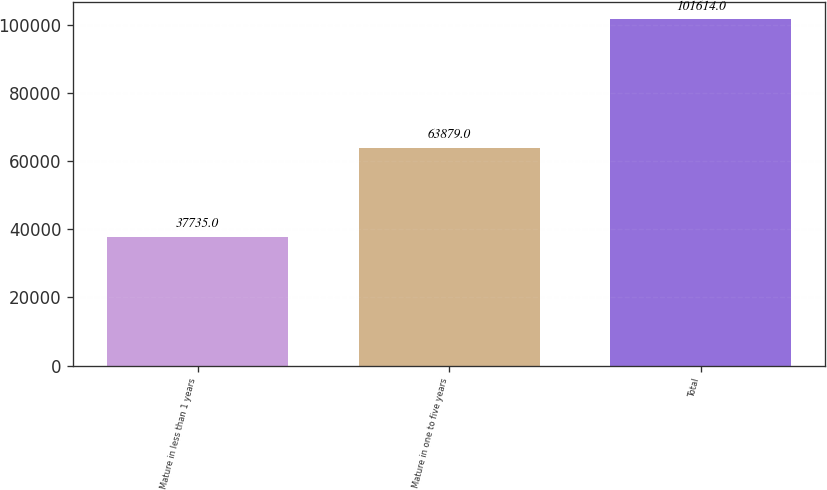Convert chart to OTSL. <chart><loc_0><loc_0><loc_500><loc_500><bar_chart><fcel>Mature in less than 1 years<fcel>Mature in one to five years<fcel>Total<nl><fcel>37735<fcel>63879<fcel>101614<nl></chart> 